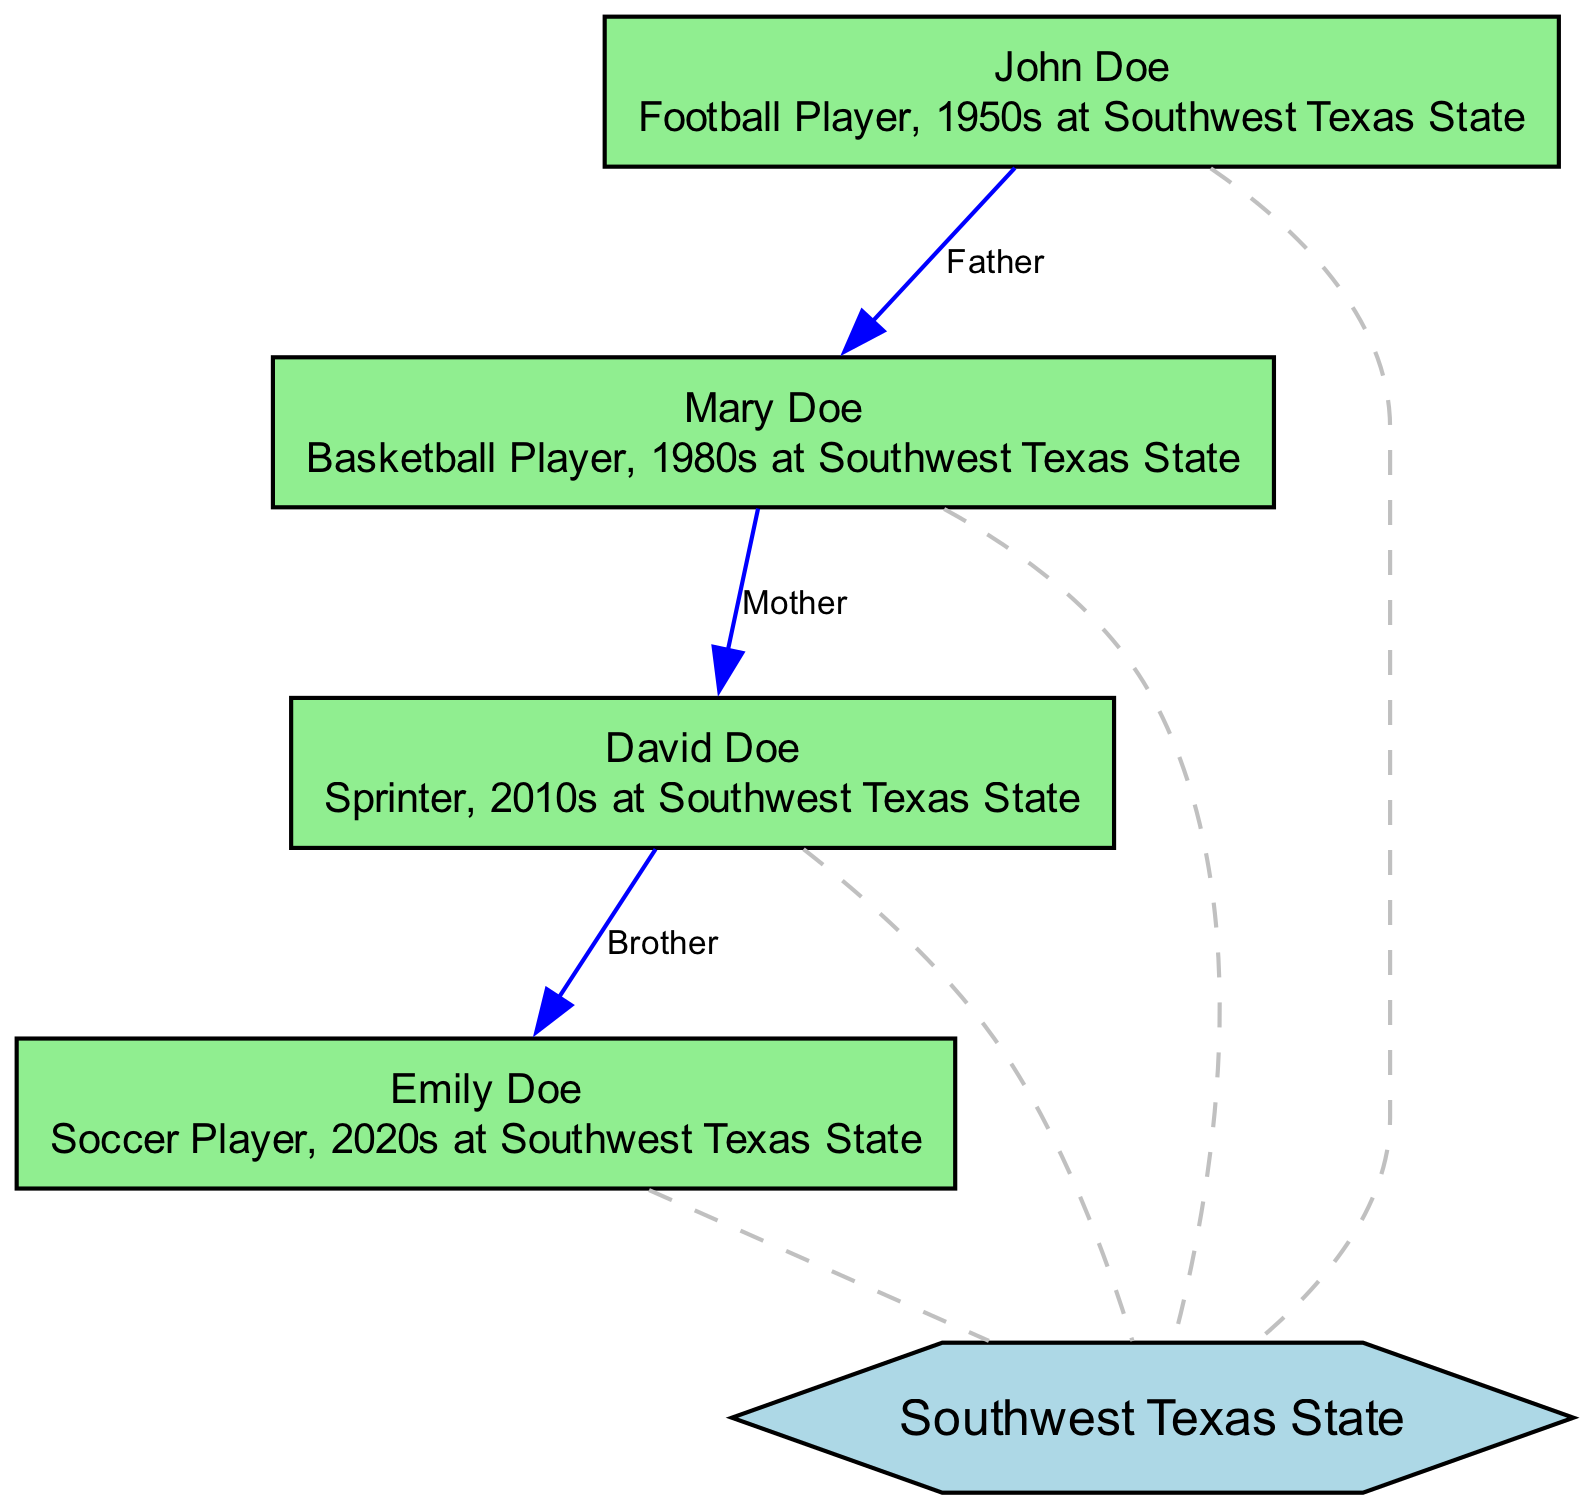What is the relationship between John Doe and Mary Doe? The diagram shows an edge labeled "Father" connecting John Doe (node 1) to Mary Doe (node 2). This indicates that John Doe is the father of Mary Doe.
Answer: Father How many nodes are there in the diagram? The diagram lists four athletes and one university node, totaling five nodes. Counting all the nodes confirms this total.
Answer: 5 What sport did David Doe play? Looking at the description provided in the diagram, David Doe (node 3) is identified as a Sprinter. This directly answers the question about his sport.
Answer: Sprinter Who is the youngest athlete in the diagram? Analyzing the timeline based on the descriptions, Emily Doe (node 4) is noted as a player in the 2020s, making her the youngest athlete compared to the others.
Answer: Emily Doe Which university is mentioned in the diagram? The diagram explicitly identifies "Southwest Texas State" (node 5) as the university connected to all the athletes represented in the nodes. This confirms the answer.
Answer: Southwest Texas State What is the connection type between David Doe and Emily Doe? The diagram indicates a "Brother" relationship going from David Doe (node 3) to Emily Doe (node 4), which clearly defines their familial connection.
Answer: Brother Which athlete played soccer? In the diagram, Emily Doe (node 4) is described as a soccer player, and this identification allows for the answer to the question regarding the sport played.
Answer: Emily Doe How many edges connect athletes to the university? The diagram shows four edges that connect each athlete node (John, Mary, David, and Emily) to the university node (Southwest Texas State). Counting these edges confirms this total.
Answer: 4 Who is the maternal figure in the family tree? The diagram indicates that Mary Doe (node 2) is the mother of David Doe (node 3), which establishes her role as the maternal figure in this part of the family tree.
Answer: Mary Doe 